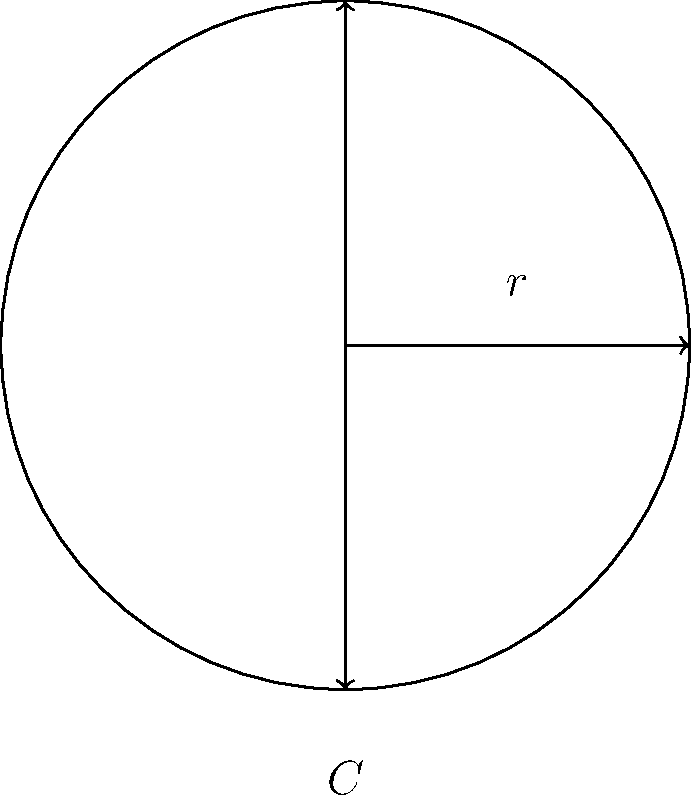In the ongoing restoration of an ancient Roman temple, you've uncovered a cylindrical stone column with a circumference of 18.84 meters. As part of your conservation efforts, you need to determine the column's radius. Using the relationship between a circle's circumference and its radius, calculate the radius of this historic column to the nearest centimeter. To find the radius of the cylindrical column, we'll use the formula that relates the circumference of a circle to its radius:

$$C = 2\pi r$$

Where:
$C$ = circumference
$\pi$ = pi (approximately 3.14159)
$r$ = radius

We're given that the circumference is 18.84 meters. Let's solve for $r$:

1) Start with the formula: $$C = 2\pi r$$

2) Substitute the known value: $$18.84 = 2\pi r$$

3) Divide both sides by $2\pi$:
   $$\frac{18.84}{2\pi} = r$$

4) Calculate:
   $$r = \frac{18.84}{2 \times 3.14159} \approx 2.9999 \text{ meters}$$

5) Rounding to the nearest centimeter:
   $$r \approx 3.00 \text{ meters}$$

Thus, the radius of the historic cylindrical column is approximately 3.00 meters or 300 centimeters.
Answer: 3.00 m 